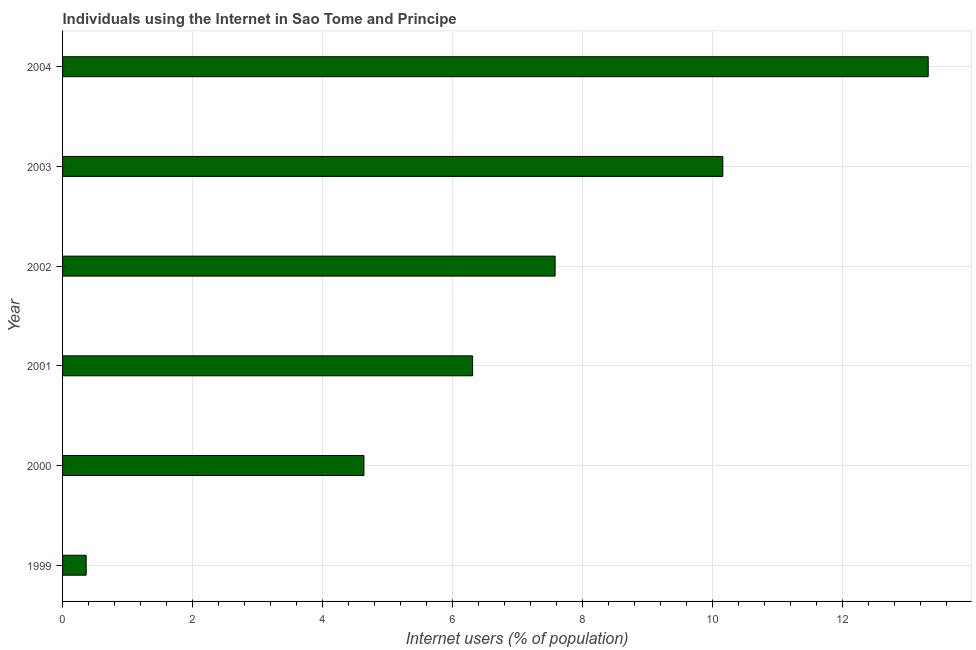Does the graph contain any zero values?
Your answer should be compact. No. Does the graph contain grids?
Your response must be concise. Yes. What is the title of the graph?
Provide a succinct answer. Individuals using the Internet in Sao Tome and Principe. What is the label or title of the X-axis?
Offer a very short reply. Internet users (% of population). What is the number of internet users in 2003?
Make the answer very short. 10.16. Across all years, what is the maximum number of internet users?
Your response must be concise. 13.32. Across all years, what is the minimum number of internet users?
Provide a short and direct response. 0.36. In which year was the number of internet users minimum?
Offer a terse response. 1999. What is the sum of the number of internet users?
Give a very brief answer. 42.38. What is the difference between the number of internet users in 1999 and 2003?
Provide a succinct answer. -9.8. What is the average number of internet users per year?
Offer a very short reply. 7.06. What is the median number of internet users?
Your response must be concise. 6.95. In how many years, is the number of internet users greater than 3.6 %?
Keep it short and to the point. 5. Do a majority of the years between 2002 and 2003 (inclusive) have number of internet users greater than 7.6 %?
Provide a short and direct response. No. What is the ratio of the number of internet users in 2003 to that in 2004?
Provide a short and direct response. 0.76. Is the difference between the number of internet users in 2001 and 2002 greater than the difference between any two years?
Offer a very short reply. No. What is the difference between the highest and the second highest number of internet users?
Your answer should be compact. 3.16. Is the sum of the number of internet users in 2001 and 2002 greater than the maximum number of internet users across all years?
Make the answer very short. Yes. What is the difference between the highest and the lowest number of internet users?
Make the answer very short. 12.96. In how many years, is the number of internet users greater than the average number of internet users taken over all years?
Your answer should be very brief. 3. Are all the bars in the graph horizontal?
Offer a terse response. Yes. Are the values on the major ticks of X-axis written in scientific E-notation?
Provide a succinct answer. No. What is the Internet users (% of population) of 1999?
Your answer should be very brief. 0.36. What is the Internet users (% of population) in 2000?
Make the answer very short. 4.64. What is the Internet users (% of population) of 2001?
Give a very brief answer. 6.31. What is the Internet users (% of population) of 2002?
Provide a succinct answer. 7.58. What is the Internet users (% of population) of 2003?
Offer a very short reply. 10.16. What is the Internet users (% of population) of 2004?
Make the answer very short. 13.32. What is the difference between the Internet users (% of population) in 1999 and 2000?
Ensure brevity in your answer.  -4.28. What is the difference between the Internet users (% of population) in 1999 and 2001?
Keep it short and to the point. -5.95. What is the difference between the Internet users (% of population) in 1999 and 2002?
Provide a short and direct response. -7.22. What is the difference between the Internet users (% of population) in 1999 and 2003?
Provide a succinct answer. -9.8. What is the difference between the Internet users (% of population) in 1999 and 2004?
Your response must be concise. -12.96. What is the difference between the Internet users (% of population) in 2000 and 2001?
Give a very brief answer. -1.67. What is the difference between the Internet users (% of population) in 2000 and 2002?
Provide a succinct answer. -2.94. What is the difference between the Internet users (% of population) in 2000 and 2003?
Provide a short and direct response. -5.52. What is the difference between the Internet users (% of population) in 2000 and 2004?
Ensure brevity in your answer.  -8.68. What is the difference between the Internet users (% of population) in 2001 and 2002?
Your response must be concise. -1.27. What is the difference between the Internet users (% of population) in 2001 and 2003?
Provide a short and direct response. -3.85. What is the difference between the Internet users (% of population) in 2001 and 2004?
Provide a short and direct response. -7.01. What is the difference between the Internet users (% of population) in 2002 and 2003?
Your answer should be very brief. -2.58. What is the difference between the Internet users (% of population) in 2002 and 2004?
Make the answer very short. -5.74. What is the difference between the Internet users (% of population) in 2003 and 2004?
Your answer should be compact. -3.16. What is the ratio of the Internet users (% of population) in 1999 to that in 2000?
Keep it short and to the point. 0.08. What is the ratio of the Internet users (% of population) in 1999 to that in 2001?
Ensure brevity in your answer.  0.06. What is the ratio of the Internet users (% of population) in 1999 to that in 2002?
Provide a succinct answer. 0.05. What is the ratio of the Internet users (% of population) in 1999 to that in 2003?
Your answer should be very brief. 0.04. What is the ratio of the Internet users (% of population) in 1999 to that in 2004?
Your answer should be compact. 0.03. What is the ratio of the Internet users (% of population) in 2000 to that in 2001?
Ensure brevity in your answer.  0.73. What is the ratio of the Internet users (% of population) in 2000 to that in 2002?
Keep it short and to the point. 0.61. What is the ratio of the Internet users (% of population) in 2000 to that in 2003?
Provide a short and direct response. 0.46. What is the ratio of the Internet users (% of population) in 2000 to that in 2004?
Offer a very short reply. 0.35. What is the ratio of the Internet users (% of population) in 2001 to that in 2002?
Offer a very short reply. 0.83. What is the ratio of the Internet users (% of population) in 2001 to that in 2003?
Give a very brief answer. 0.62. What is the ratio of the Internet users (% of population) in 2001 to that in 2004?
Your answer should be very brief. 0.47. What is the ratio of the Internet users (% of population) in 2002 to that in 2003?
Provide a short and direct response. 0.75. What is the ratio of the Internet users (% of population) in 2002 to that in 2004?
Offer a very short reply. 0.57. What is the ratio of the Internet users (% of population) in 2003 to that in 2004?
Your answer should be compact. 0.76. 